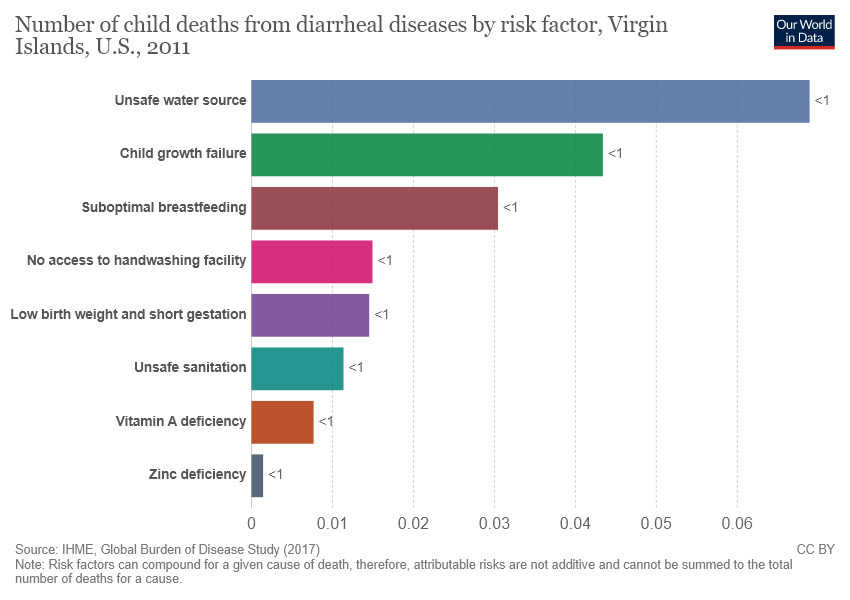Identify some key points in this picture. Green bar category refers to child growth failure. 